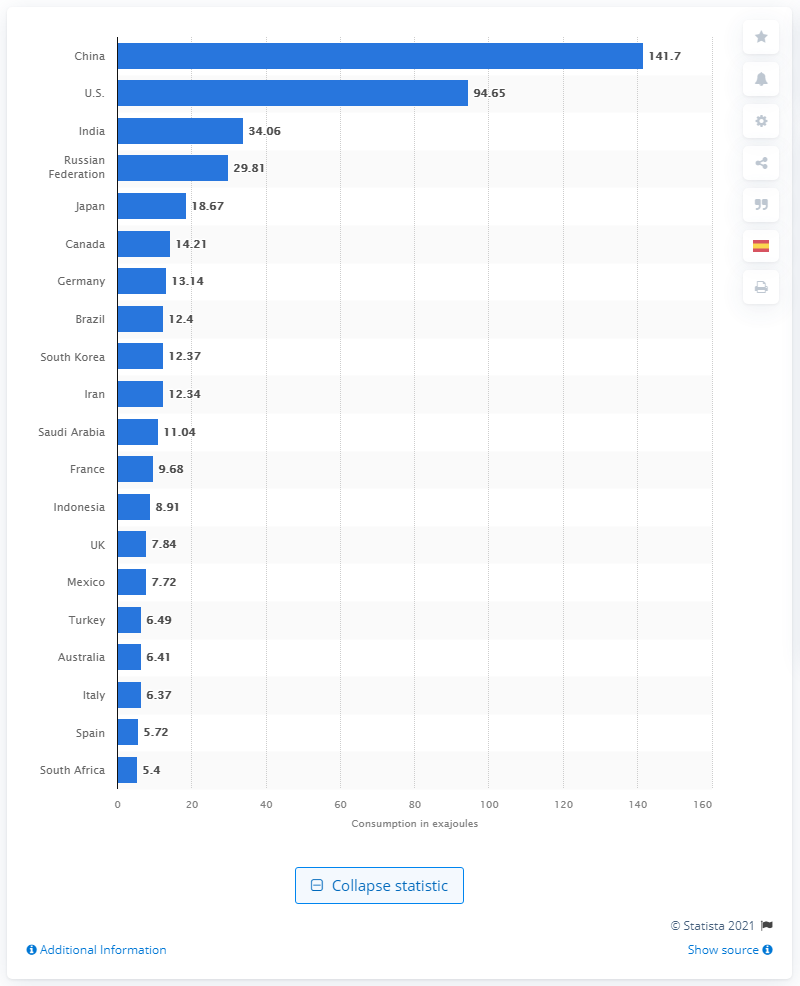Identify some key points in this picture. In 2019, China consumed 141.7 exajoules of energy. 